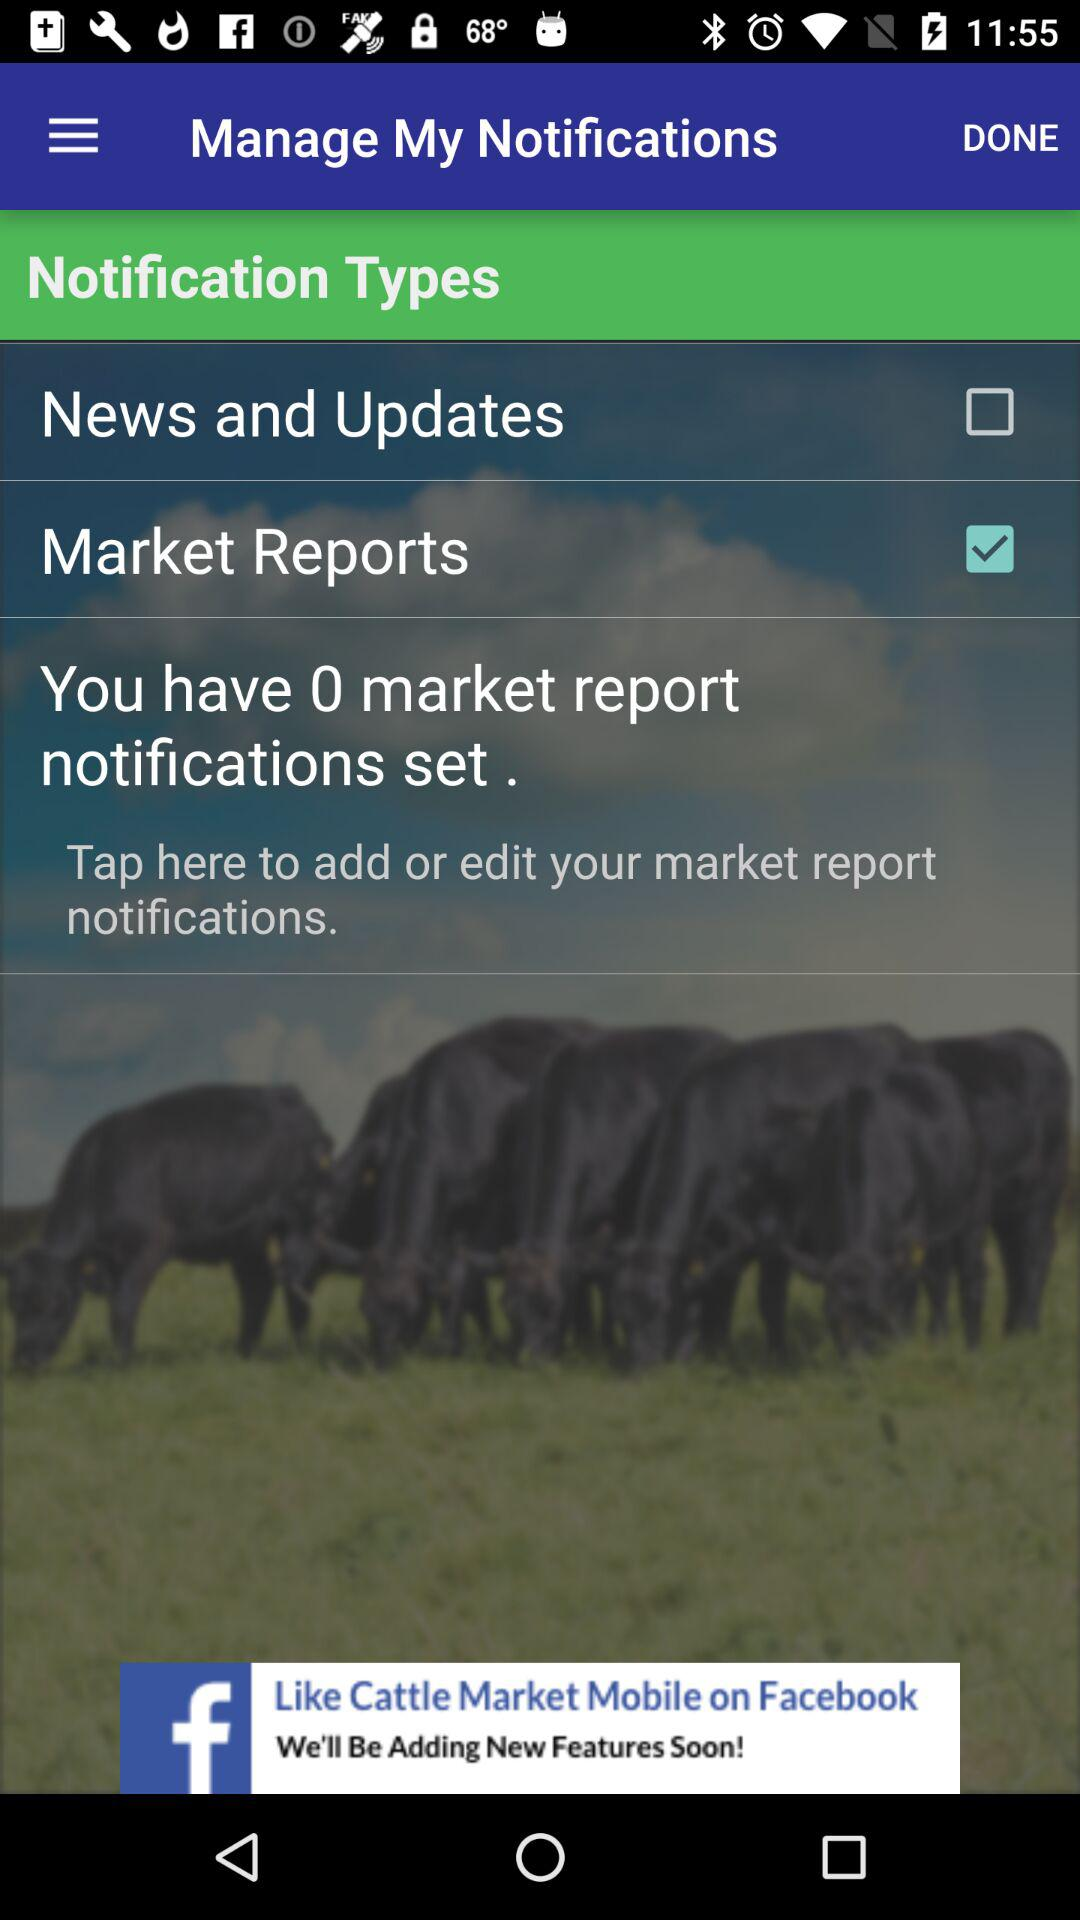How many notifications have been set?
Answer the question using a single word or phrase. 0 